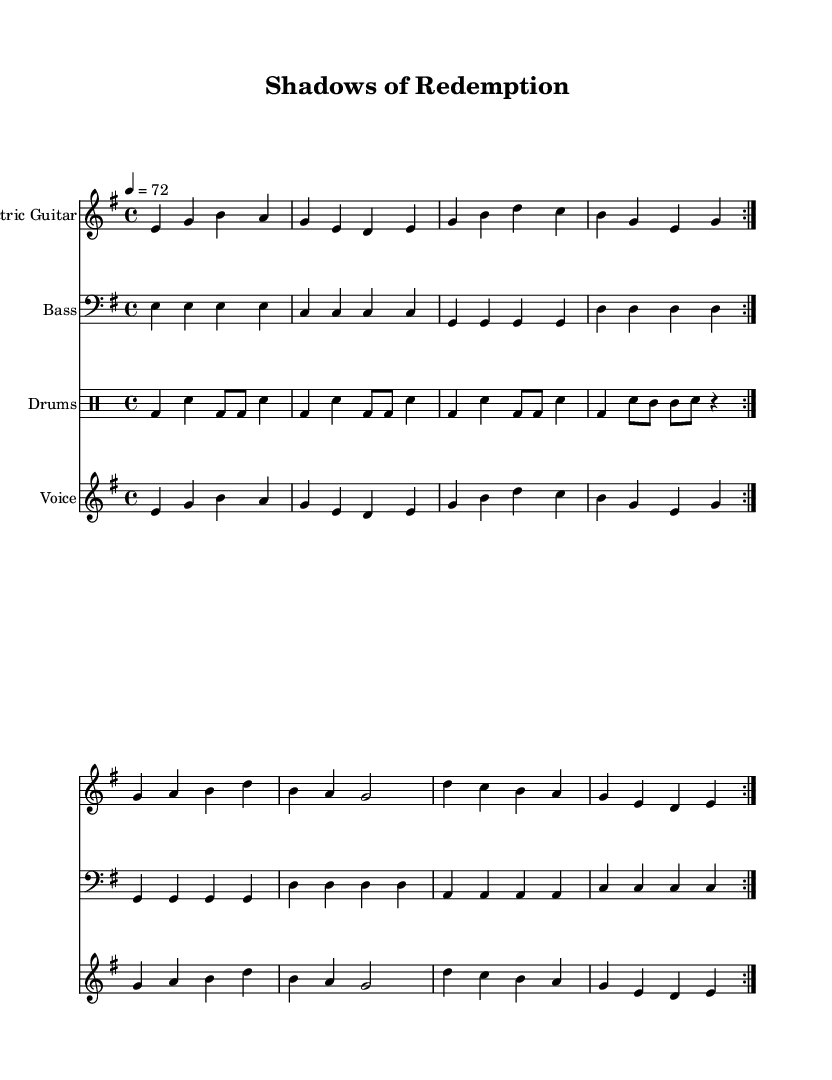What is the key signature of this music? The key signature is E minor, indicated by one sharp (F#), which affects the notes played throughout the piece.
Answer: E minor What is the time signature of this music? The time signature is 4/4, which means there are four beats in a measure and each quarter note gets one beat.
Answer: 4/4 What is the tempo mark for this piece? The tempo is marked as 72 beats per minute, which means the piece should be played moderately slowly, giving a laid-back feel typical of grunge music.
Answer: 72 How many times is the main theme repeated? The main theme, as indicated by "repeat volta 2", suggests that the section is played twice, allowing for emphasis on the themes of pain and redemption.
Answer: 2 What instruments are used in the score? The score features an Electric Guitar, Bass, Drums, and Voice, which are all standard in rock music, especially in the grunge subgenre, emphasizing heaviness and melody.
Answer: Electric Guitar, Bass, Drums, Voice What lyrical theme is explored in the song? The lyrics focus on themes of shadows from the past and searching for redemption, highlighting a narrative common in grunge that deals with personal struggles and emotional pain.
Answer: Pain and redemption 